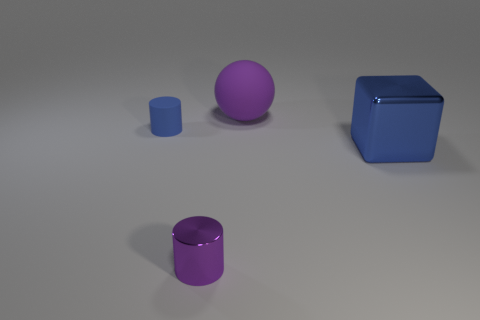Subtract all red cylinders. Subtract all brown blocks. How many cylinders are left? 2 Add 3 rubber cylinders. How many objects exist? 7 Subtract all spheres. How many objects are left? 3 Add 2 big blue things. How many big blue things are left? 3 Add 1 small brown cylinders. How many small brown cylinders exist? 1 Subtract 0 brown cylinders. How many objects are left? 4 Subtract all large gray balls. Subtract all shiny blocks. How many objects are left? 3 